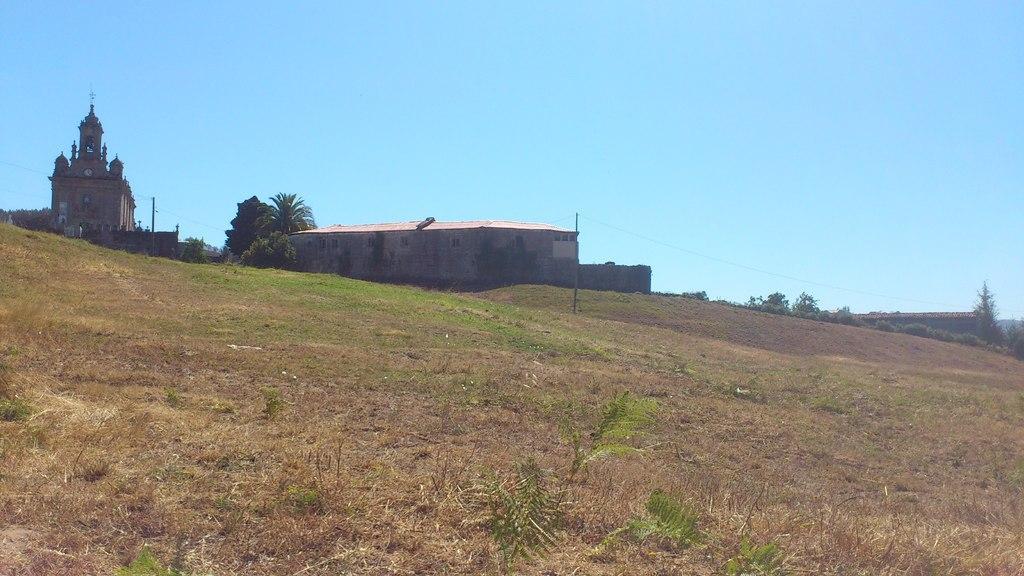Describe this image in one or two sentences. In this image there are few buildings on the land having few plants and trees. Top of image there is sky. Bottom of image there is some grass and plants on the land. 